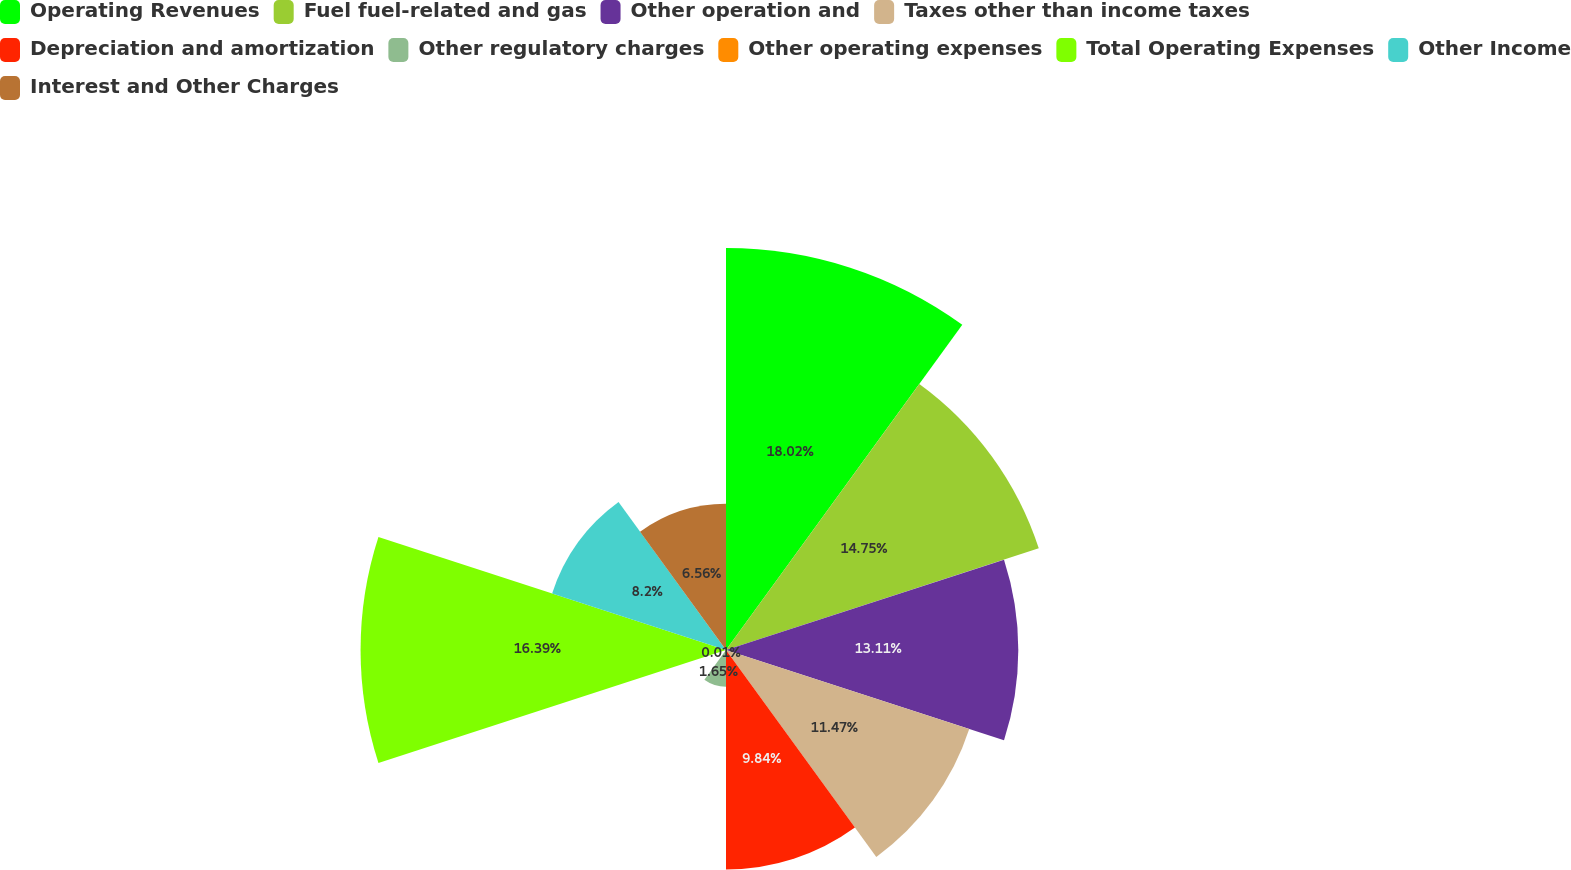<chart> <loc_0><loc_0><loc_500><loc_500><pie_chart><fcel>Operating Revenues<fcel>Fuel fuel-related and gas<fcel>Other operation and<fcel>Taxes other than income taxes<fcel>Depreciation and amortization<fcel>Other regulatory charges<fcel>Other operating expenses<fcel>Total Operating Expenses<fcel>Other Income<fcel>Interest and Other Charges<nl><fcel>18.03%<fcel>14.75%<fcel>13.11%<fcel>11.47%<fcel>9.84%<fcel>1.65%<fcel>0.01%<fcel>16.39%<fcel>8.2%<fcel>6.56%<nl></chart> 